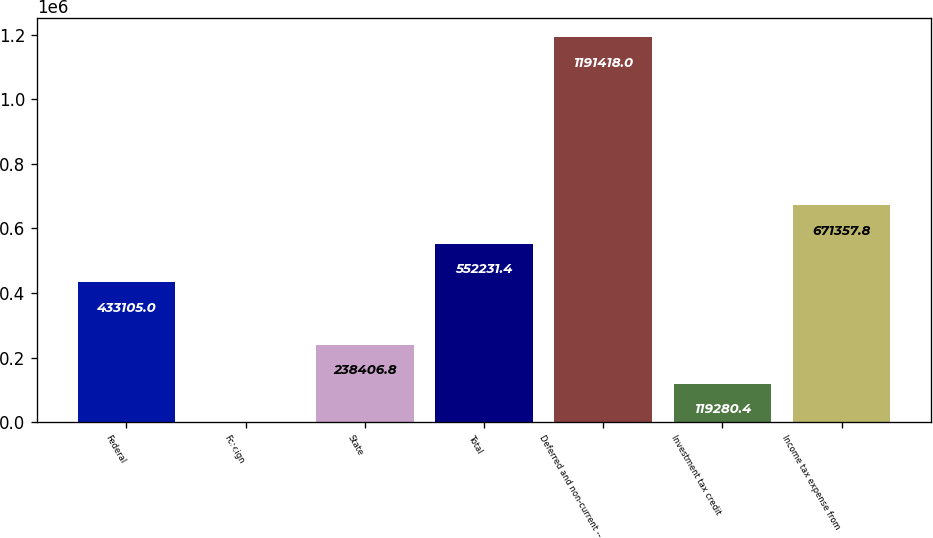Convert chart. <chart><loc_0><loc_0><loc_500><loc_500><bar_chart><fcel>Federal<fcel>Foreign<fcel>State<fcel>Total<fcel>Deferred and non-current --<fcel>Investment tax credit<fcel>Income tax expense from<nl><fcel>433105<fcel>154<fcel>238407<fcel>552231<fcel>1.19142e+06<fcel>119280<fcel>671358<nl></chart> 